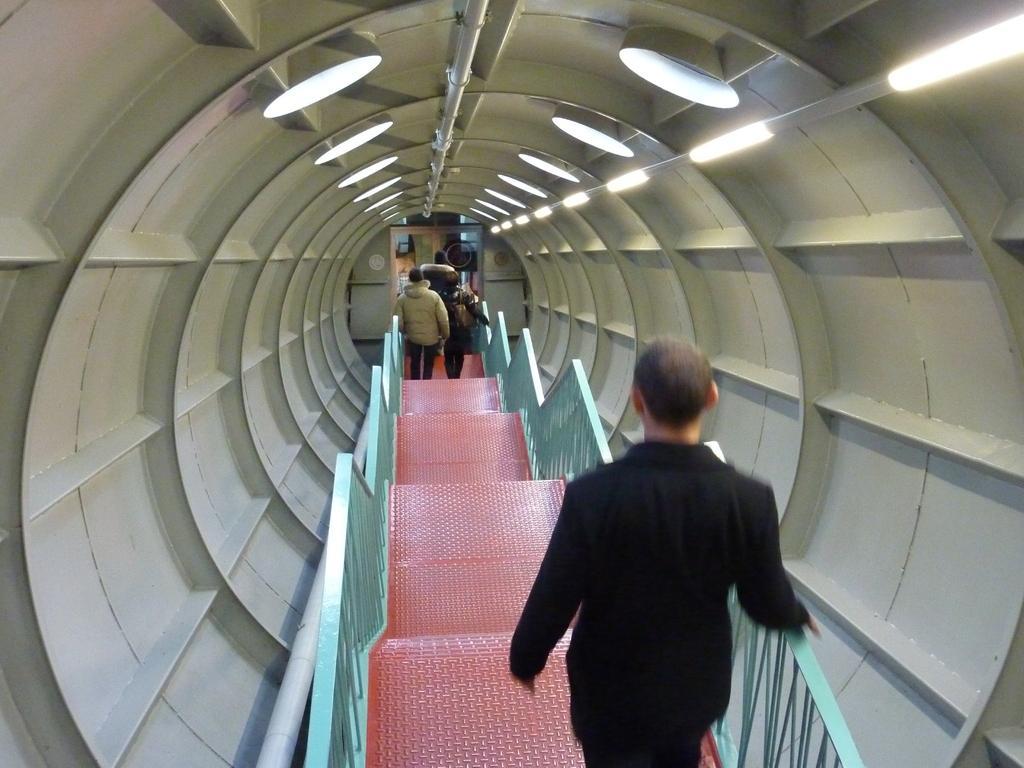Could you give a brief overview of what you see in this image? In this image we can see a group of people standing on staircase with railing inside the tunnel. In the background, we can see group of lights and doors. 